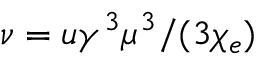<formula> <loc_0><loc_0><loc_500><loc_500>\nu = u \gamma ^ { 3 } \mu ^ { 3 } / ( 3 \chi _ { e } )</formula> 